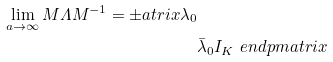<formula> <loc_0><loc_0><loc_500><loc_500>\lim _ { a \to \infty } M \varLambda M ^ { - 1 } = \pm a t r i x \lambda _ { 0 } & \\ & \bar { \lambda } _ { 0 } I _ { K } \ e n d p m a t r i x</formula> 